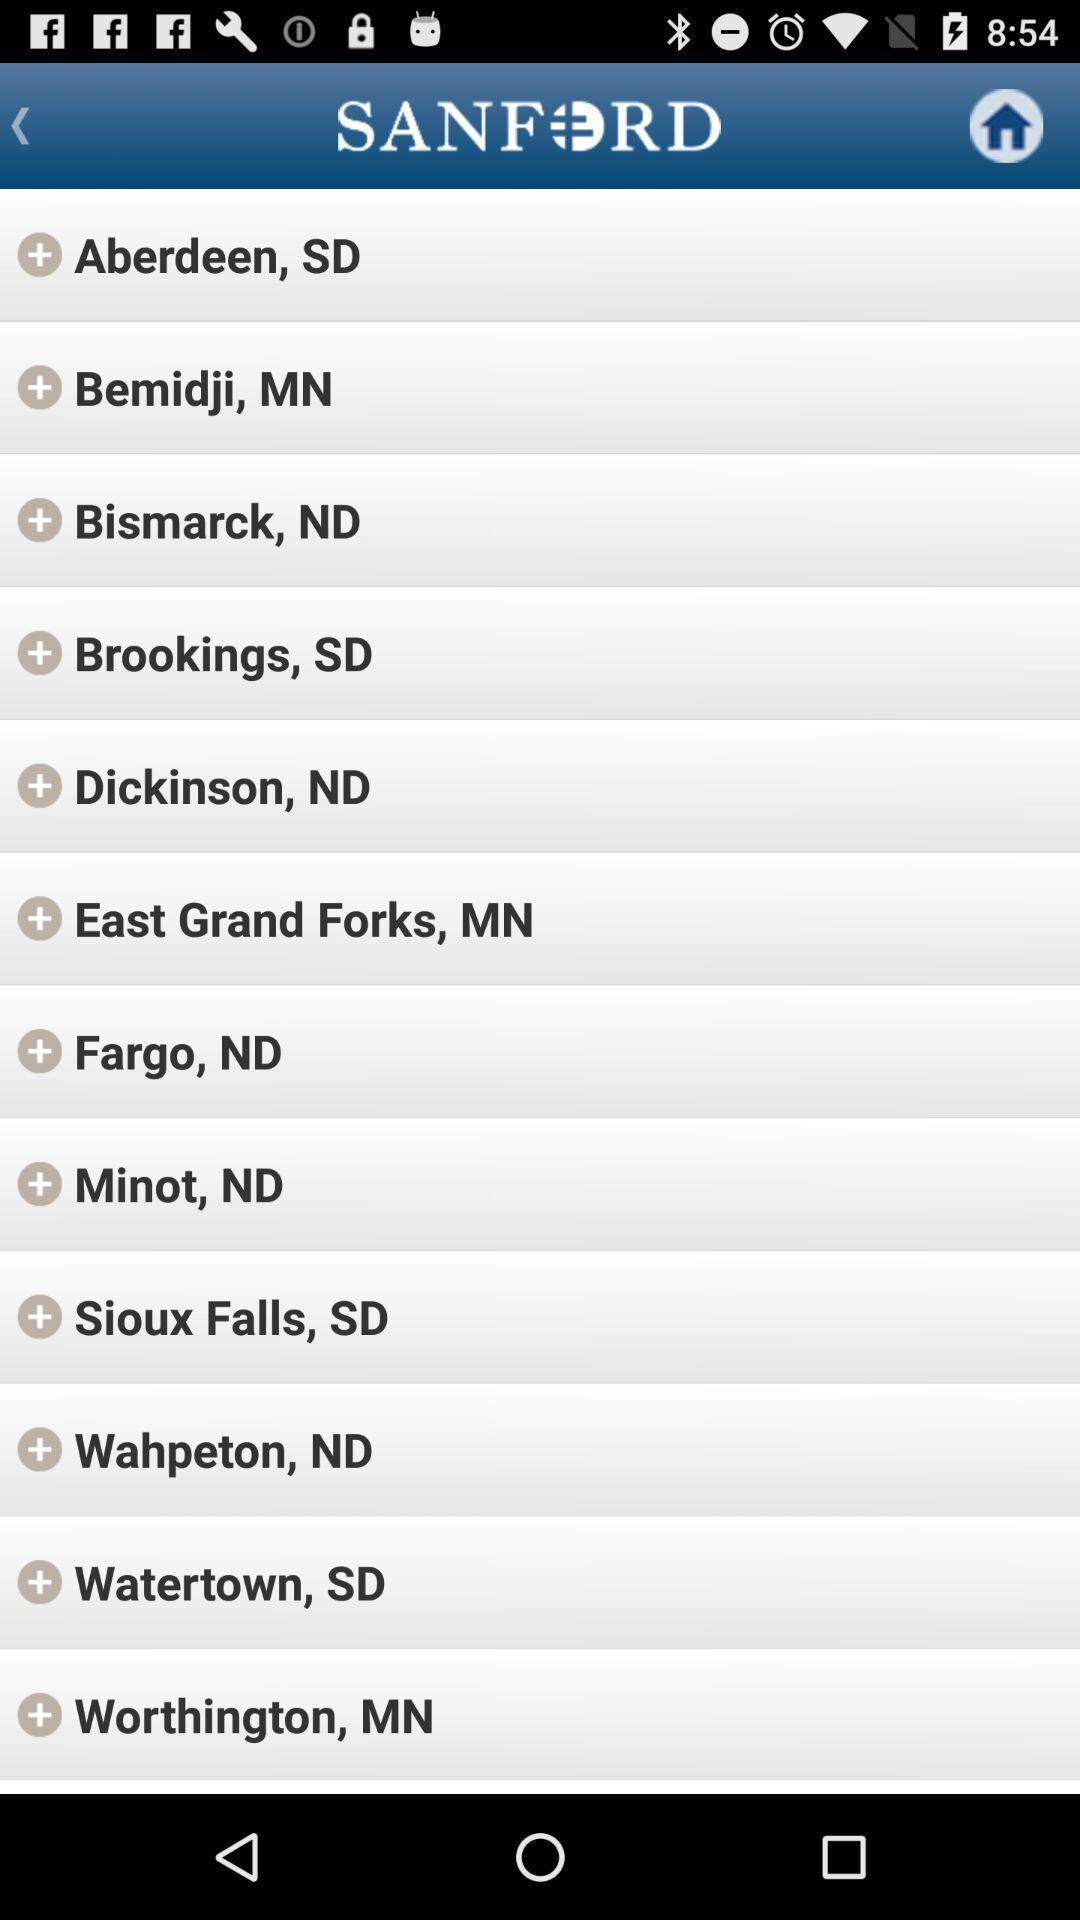What is the name of the application? The name of the application is "SANFORD". 